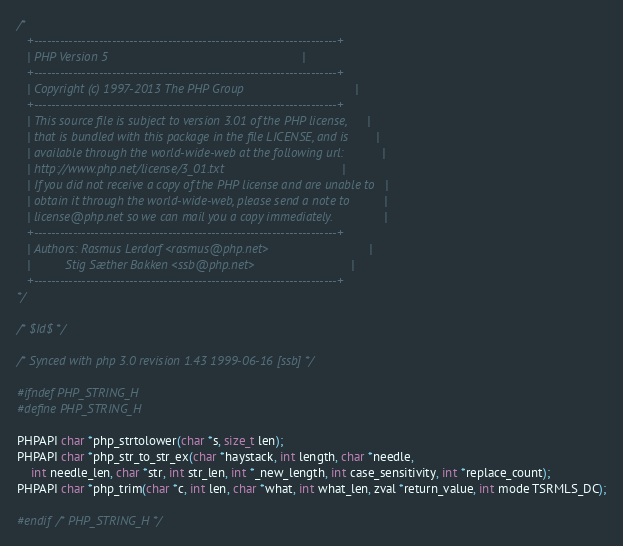Convert code to text. <code><loc_0><loc_0><loc_500><loc_500><_C_>/* 
   +----------------------------------------------------------------------+
   | PHP Version 5                                                        |
   +----------------------------------------------------------------------+
   | Copyright (c) 1997-2013 The PHP Group                                |
   +----------------------------------------------------------------------+
   | This source file is subject to version 3.01 of the PHP license,      |
   | that is bundled with this package in the file LICENSE, and is        |
   | available through the world-wide-web at the following url:           |
   | http://www.php.net/license/3_01.txt                                  |
   | If you did not receive a copy of the PHP license and are unable to   |
   | obtain it through the world-wide-web, please send a note to          |
   | license@php.net so we can mail you a copy immediately.               |
   +----------------------------------------------------------------------+
   | Authors: Rasmus Lerdorf <rasmus@php.net>                             |
   |          Stig Sæther Bakken <ssb@php.net>                            |
   +----------------------------------------------------------------------+
*/

/* $Id$ */

/* Synced with php 3.0 revision 1.43 1999-06-16 [ssb] */

#ifndef PHP_STRING_H
#define PHP_STRING_H

PHPAPI char *php_strtolower(char *s, size_t len);
PHPAPI char *php_str_to_str_ex(char *haystack, int length, char *needle,
    int needle_len, char *str, int str_len, int *_new_length, int case_sensitivity, int *replace_count);
PHPAPI char *php_trim(char *c, int len, char *what, int what_len, zval *return_value, int mode TSRMLS_DC);

#endif /* PHP_STRING_H */
</code> 